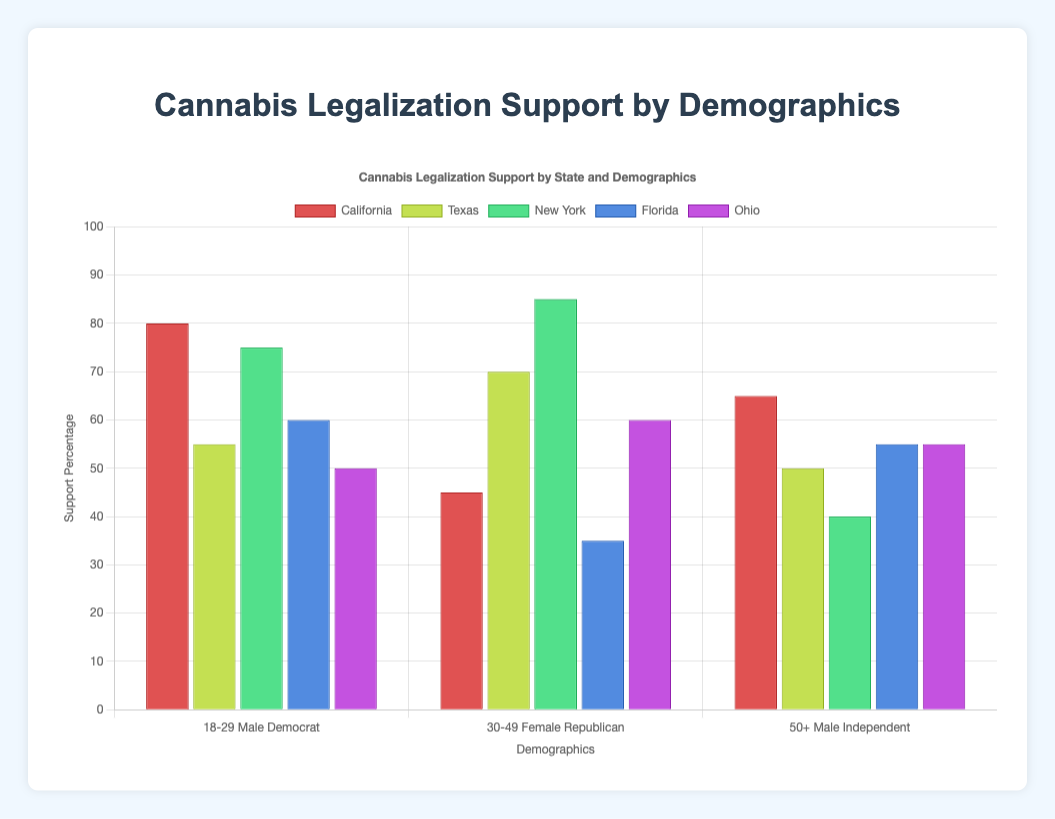What is the average support percentage for cannabis legalization in California across all demographic groups? To find the average support percentage in California, sum the support percentages (80, 45, 65) and divide by the number of demographic groups (3). Hence, (80 + 45 + 65) / 3 = 63.33.
Answer: 63.33 Which state shows the highest support percentage for cannabis legalization among any demographic group? In the chart, the highest support percentage is 85%, which is observed in New York for the demographic group of females aged 30-49 and affiliated with the Democrat party.
Answer: New York Among the states, which gender in the age group 18-29 has the lowest support percentage for cannabis legalization? The support percentages for 18-29 age group in each state are: Male in California (80), Female in Texas (55), Male in New York (75), Female in Florida (60), Male in Ohio (50). The lowest percentage is 50% observed in Ohio.
Answer: Male In Texas, how much higher is the support percentage for cannabis legalization among Democrats aged 30-49 compared to Independents aged 50+? The support percentage for Democrats aged 30-49 in Texas is 70%, and for Independents aged 50+ it is 50%. The difference is 70 - 50 = 20 percentage points.
Answer: 20 Which political affiliation shows the most support for cannabis legalization among the 50+ age group across all states? In the 50+ age group: California (65 Independent), Texas (50 Independent), New York (40 Republican), Florida (55 Independent), Ohio (55 Democrat). The highest support percentage of 65% is among Independents in California.
Answer: Independent Which state has the lowest overall support percentage for cannabis legalization in any demographic group? The lowest support percentage observed is 35% for males aged 30-49 and affiliated with the Republican party in Florida.
Answer: Florida Compare and contrast the support percentages for cannabis legalization between Democrats and Republicans in the state of Florida. In Florida, the support percentage for Democrats (females aged 18-29) is 60%, and for Republicans (males aged 30-49) is 35%. Democrats show 25 percentage points higher support than Republicans.
Answer: Democrats show higher support Considering only the male demographic across all states, which age group shows the highest support percentage for cannabis legalization? Among males: 18-29 in California (80), 50+ in California (65), 30-49 in Texas (70), 18-29 in New York (75), 50+ in New York (40), 18-29 in Ohio (50), 50+ in Ohio (55). The highest support is 80% for 18-29 in California.
Answer: 18-29 in California What is the difference in support percentage for cannabis legalization between Independents in the state of Ohio and Independents in California for the 50+ age group? The support percentage for Independents aged 50+ in Ohio is 60%, and in California, it is 65%. The difference is 65 - 60 = 5 percentage points.
Answer: 5 